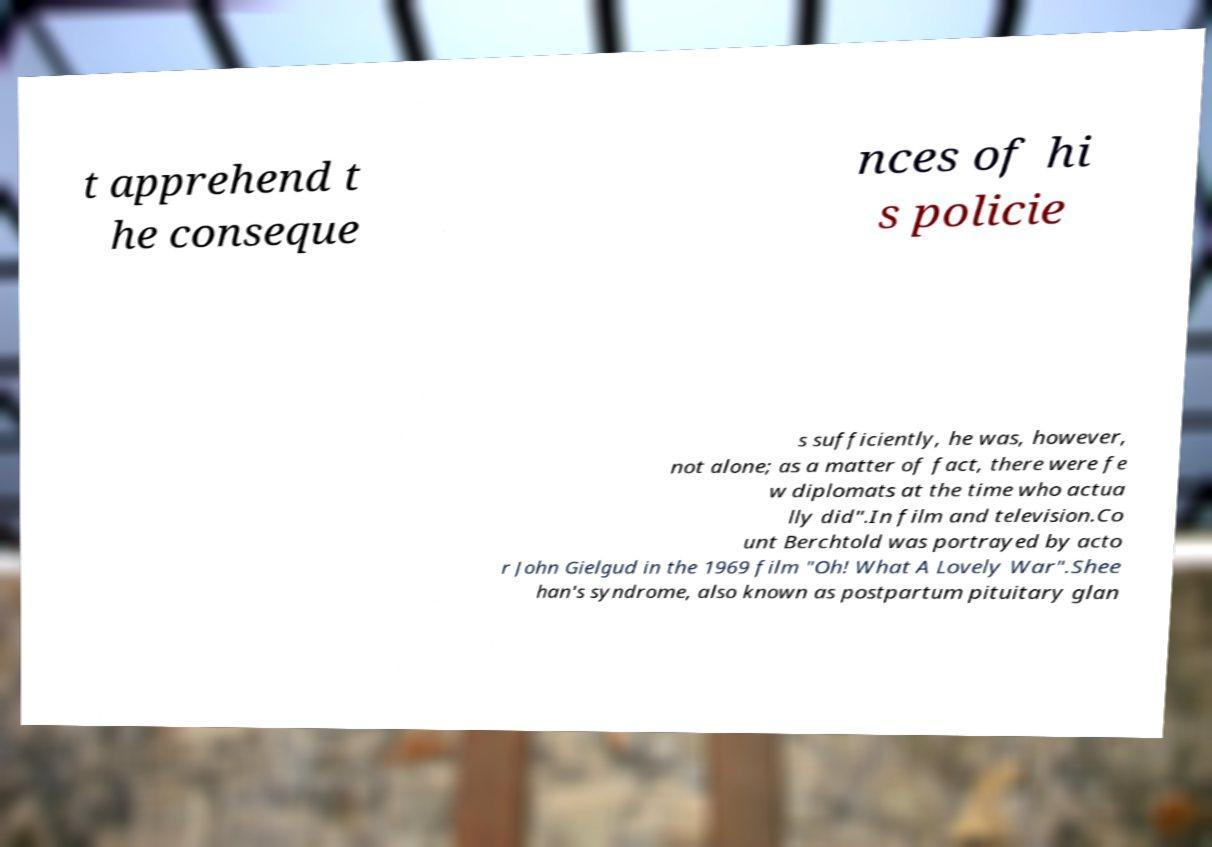What messages or text are displayed in this image? I need them in a readable, typed format. t apprehend t he conseque nces of hi s policie s sufficiently, he was, however, not alone; as a matter of fact, there were fe w diplomats at the time who actua lly did".In film and television.Co unt Berchtold was portrayed by acto r John Gielgud in the 1969 film "Oh! What A Lovely War".Shee han's syndrome, also known as postpartum pituitary glan 